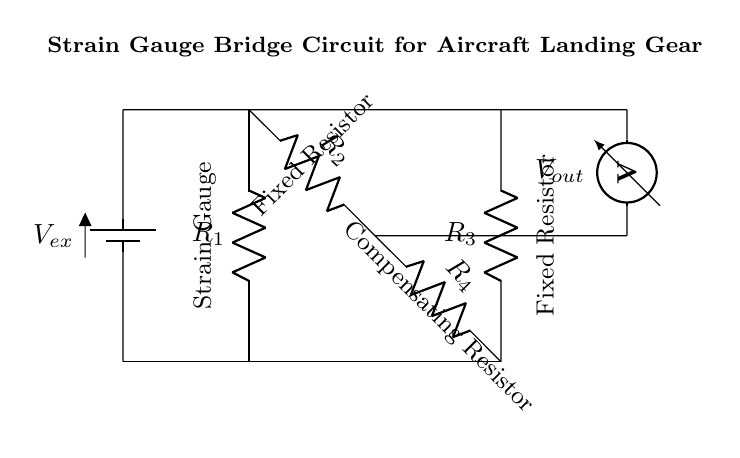What components are used in the strain gauge bridge? The components in the strain gauge bridge circuit are R1, R2, R3, R4, a voltage source labeled as Vex, and a voltmeter labeled as Vout. These components are essential for measuring strain through the changes in resistance caused by stress on the landing gear.
Answer: R1, R2, R3, R4, Vex, Vout What is the purpose of the voltage source? The voltage source, labeled Vex, provides the necessary excitation voltage to the bridge circuit. This voltage is required to create a potential difference across the resistors so that variations in resistance (due to strain) can be measured as changes in voltage output.
Answer: Excitation voltage How many resistors are fixed in the circuit? In this bridge circuit, there are two fixed resistors labeled R2 and R4. They help to balance the bridge and ensure that the strain gauge measurements remain accurate by compensating for variations.
Answer: Two What does Vout represent in this circuit? Vout, the voltmeter reading in the circuit, represents the output voltage, which indicates the difference in potential between the two branches of the bridge. This voltage change is directly linked to the amount of strain experienced by the landing gear.
Answer: Output voltage What happens to Vout when the strain gauge experiences stress? When the strain gauge experiences stress, it changes its resistance, resulting in an imbalance in the bridge circuit. This imbalance leads to a change in output voltage Vout, which provides an indication of the magnitude of the stress applied to the landing gear.
Answer: Changes 